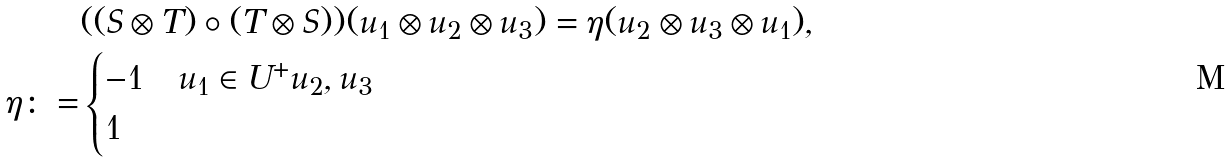Convert formula to latex. <formula><loc_0><loc_0><loc_500><loc_500>& ( ( S \otimes T ) \circ ( T \otimes S ) ) ( u _ { 1 } \otimes u _ { 2 } \otimes u _ { 3 } ) = \eta ( u _ { 2 } \otimes u _ { 3 } \otimes u _ { 1 } ) , \\ \eta \colon = & \begin{cases} - 1 & u _ { 1 } \in U ^ { + } u _ { 2 } , u _ { 3 } \\ 1 & \end{cases}</formula> 